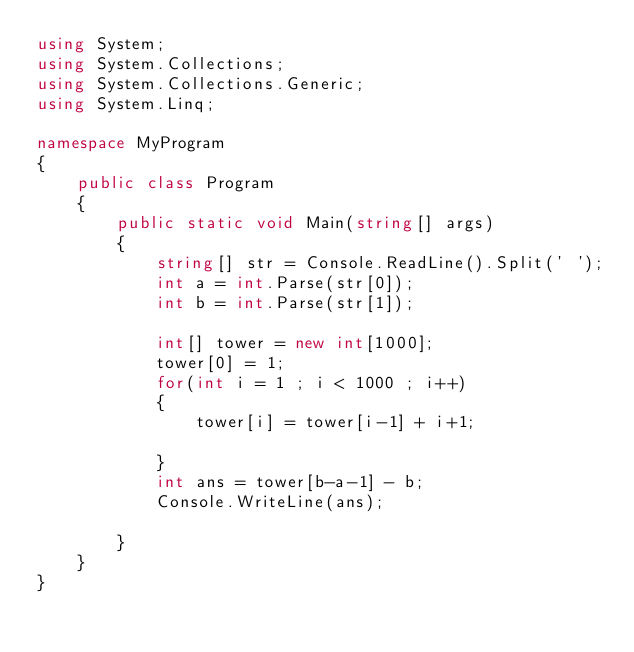Convert code to text. <code><loc_0><loc_0><loc_500><loc_500><_C#_>using System;
using System.Collections;
using System.Collections.Generic;
using System.Linq;

namespace MyProgram
{
    public class Program
    {	
        public static void Main(string[] args)
        {
            string[] str = Console.ReadLine().Split(' ');
            int a = int.Parse(str[0]);
            int b = int.Parse(str[1]);
            
            int[] tower = new int[1000];
            tower[0] = 1;
            for(int i = 1 ; i < 1000 ; i++)
            {
                tower[i] = tower[i-1] + i+1;
               
            }
            int ans = tower[b-a-1] - b;
            Console.WriteLine(ans);
            
        }
    }
}</code> 